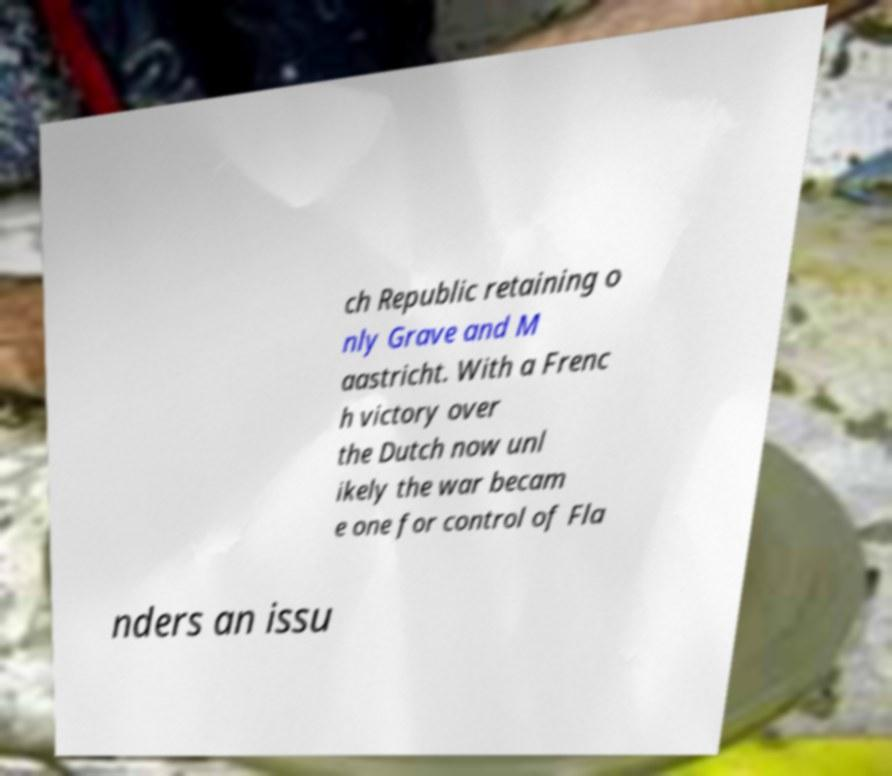I need the written content from this picture converted into text. Can you do that? ch Republic retaining o nly Grave and M aastricht. With a Frenc h victory over the Dutch now unl ikely the war becam e one for control of Fla nders an issu 